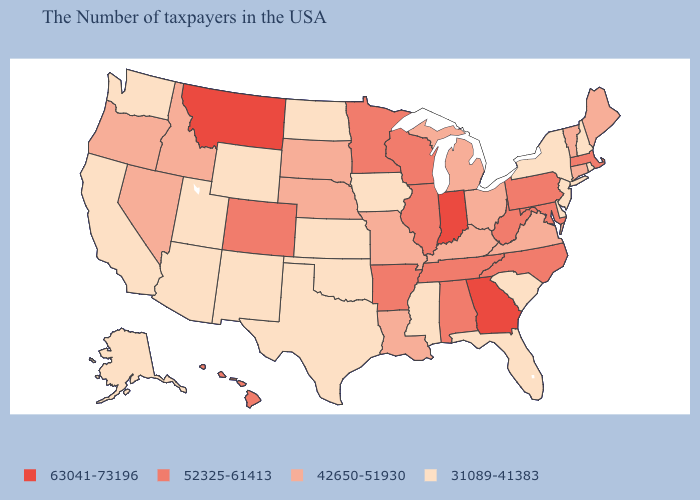Does Wisconsin have a higher value than Georgia?
Give a very brief answer. No. Does Missouri have the same value as Rhode Island?
Concise answer only. No. How many symbols are there in the legend?
Be succinct. 4. How many symbols are there in the legend?
Be succinct. 4. What is the lowest value in the Northeast?
Concise answer only. 31089-41383. What is the value of Hawaii?
Answer briefly. 52325-61413. Does the first symbol in the legend represent the smallest category?
Be succinct. No. Does Maine have a higher value than South Dakota?
Write a very short answer. No. What is the value of Alabama?
Give a very brief answer. 52325-61413. What is the value of Massachusetts?
Give a very brief answer. 52325-61413. Among the states that border New Jersey , which have the highest value?
Concise answer only. Pennsylvania. Does Maine have a lower value than Pennsylvania?
Keep it brief. Yes. Does Indiana have the highest value in the MidWest?
Short answer required. Yes. What is the value of New Hampshire?
Keep it brief. 31089-41383. 